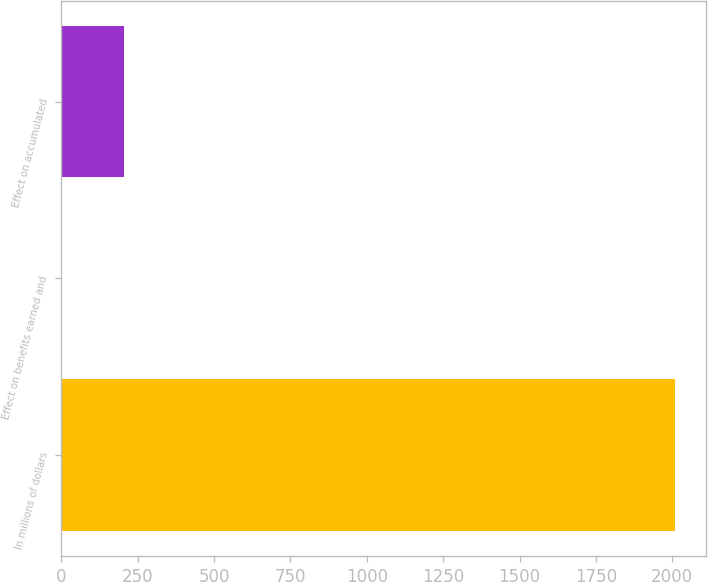<chart> <loc_0><loc_0><loc_500><loc_500><bar_chart><fcel>In millions of dollars<fcel>Effect on benefits earned and<fcel>Effect on accumulated<nl><fcel>2009<fcel>3<fcel>203.6<nl></chart> 